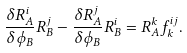<formula> <loc_0><loc_0><loc_500><loc_500>\frac { \delta R _ { A } ^ { i } } { \delta \phi _ { B } } R _ { B } ^ { j } - \frac { \delta R _ { A } ^ { j } } { \delta \phi _ { B } } R _ { B } ^ { i } = R _ { A } ^ { k } f _ { k } ^ { i j } .</formula> 